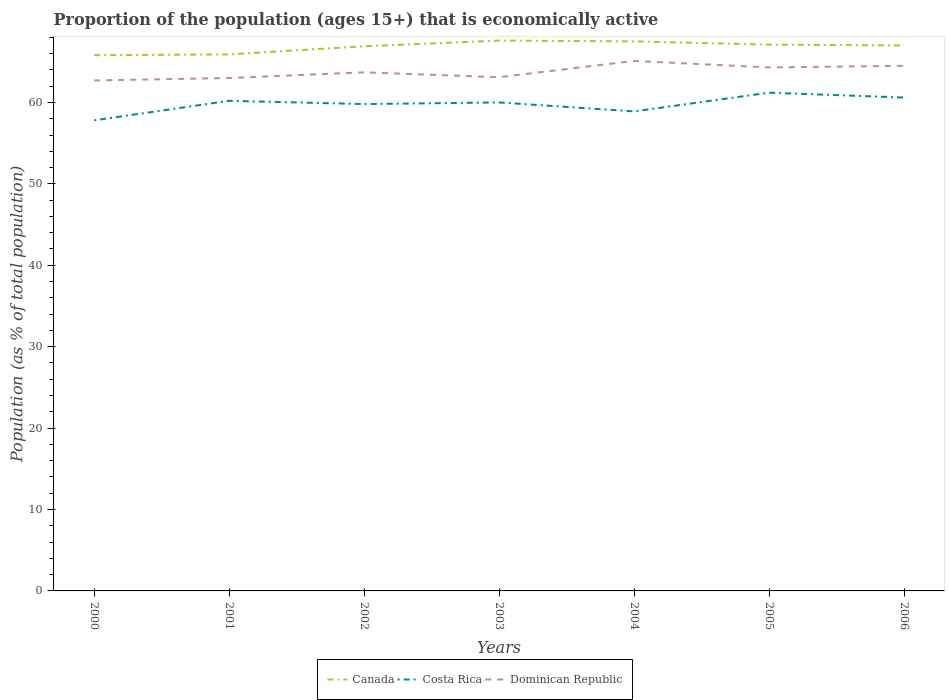Across all years, what is the maximum proportion of the population that is economically active in Canada?
Keep it short and to the point. 65.8. In which year was the proportion of the population that is economically active in Dominican Republic maximum?
Offer a terse response. 2000. What is the total proportion of the population that is economically active in Dominican Republic in the graph?
Give a very brief answer. -0.1. What is the difference between the highest and the second highest proportion of the population that is economically active in Costa Rica?
Keep it short and to the point. 3.4. Is the proportion of the population that is economically active in Costa Rica strictly greater than the proportion of the population that is economically active in Canada over the years?
Provide a succinct answer. Yes. How many years are there in the graph?
Your answer should be very brief. 7. Does the graph contain any zero values?
Keep it short and to the point. No. How are the legend labels stacked?
Offer a terse response. Horizontal. What is the title of the graph?
Your answer should be very brief. Proportion of the population (ages 15+) that is economically active. Does "Congo (Democratic)" appear as one of the legend labels in the graph?
Offer a very short reply. No. What is the label or title of the X-axis?
Make the answer very short. Years. What is the label or title of the Y-axis?
Offer a terse response. Population (as % of total population). What is the Population (as % of total population) in Canada in 2000?
Give a very brief answer. 65.8. What is the Population (as % of total population) of Costa Rica in 2000?
Keep it short and to the point. 57.8. What is the Population (as % of total population) in Dominican Republic in 2000?
Your answer should be compact. 62.7. What is the Population (as % of total population) in Canada in 2001?
Offer a terse response. 65.9. What is the Population (as % of total population) of Costa Rica in 2001?
Your answer should be compact. 60.2. What is the Population (as % of total population) of Canada in 2002?
Your answer should be very brief. 66.9. What is the Population (as % of total population) of Costa Rica in 2002?
Keep it short and to the point. 59.8. What is the Population (as % of total population) in Dominican Republic in 2002?
Your answer should be very brief. 63.7. What is the Population (as % of total population) in Canada in 2003?
Your answer should be very brief. 67.6. What is the Population (as % of total population) in Costa Rica in 2003?
Keep it short and to the point. 60. What is the Population (as % of total population) of Dominican Republic in 2003?
Keep it short and to the point. 63.1. What is the Population (as % of total population) in Canada in 2004?
Keep it short and to the point. 67.5. What is the Population (as % of total population) of Costa Rica in 2004?
Provide a succinct answer. 58.9. What is the Population (as % of total population) of Dominican Republic in 2004?
Offer a very short reply. 65.1. What is the Population (as % of total population) in Canada in 2005?
Provide a succinct answer. 67.1. What is the Population (as % of total population) in Costa Rica in 2005?
Offer a terse response. 61.2. What is the Population (as % of total population) in Dominican Republic in 2005?
Ensure brevity in your answer.  64.3. What is the Population (as % of total population) in Canada in 2006?
Keep it short and to the point. 67. What is the Population (as % of total population) of Costa Rica in 2006?
Provide a succinct answer. 60.6. What is the Population (as % of total population) in Dominican Republic in 2006?
Keep it short and to the point. 64.5. Across all years, what is the maximum Population (as % of total population) of Canada?
Ensure brevity in your answer.  67.6. Across all years, what is the maximum Population (as % of total population) in Costa Rica?
Keep it short and to the point. 61.2. Across all years, what is the maximum Population (as % of total population) of Dominican Republic?
Keep it short and to the point. 65.1. Across all years, what is the minimum Population (as % of total population) of Canada?
Provide a succinct answer. 65.8. Across all years, what is the minimum Population (as % of total population) in Costa Rica?
Keep it short and to the point. 57.8. Across all years, what is the minimum Population (as % of total population) in Dominican Republic?
Provide a succinct answer. 62.7. What is the total Population (as % of total population) in Canada in the graph?
Make the answer very short. 467.8. What is the total Population (as % of total population) of Costa Rica in the graph?
Provide a succinct answer. 418.5. What is the total Population (as % of total population) of Dominican Republic in the graph?
Provide a short and direct response. 446.4. What is the difference between the Population (as % of total population) in Costa Rica in 2000 and that in 2001?
Your answer should be very brief. -2.4. What is the difference between the Population (as % of total population) in Canada in 2000 and that in 2002?
Your answer should be compact. -1.1. What is the difference between the Population (as % of total population) of Dominican Republic in 2000 and that in 2006?
Your answer should be very brief. -1.8. What is the difference between the Population (as % of total population) of Canada in 2001 and that in 2002?
Your response must be concise. -1. What is the difference between the Population (as % of total population) of Dominican Republic in 2001 and that in 2002?
Make the answer very short. -0.7. What is the difference between the Population (as % of total population) of Canada in 2001 and that in 2003?
Provide a short and direct response. -1.7. What is the difference between the Population (as % of total population) in Costa Rica in 2001 and that in 2003?
Give a very brief answer. 0.2. What is the difference between the Population (as % of total population) in Dominican Republic in 2001 and that in 2003?
Ensure brevity in your answer.  -0.1. What is the difference between the Population (as % of total population) in Costa Rica in 2001 and that in 2004?
Offer a very short reply. 1.3. What is the difference between the Population (as % of total population) in Canada in 2001 and that in 2005?
Give a very brief answer. -1.2. What is the difference between the Population (as % of total population) in Dominican Republic in 2001 and that in 2005?
Ensure brevity in your answer.  -1.3. What is the difference between the Population (as % of total population) of Canada in 2001 and that in 2006?
Offer a very short reply. -1.1. What is the difference between the Population (as % of total population) in Dominican Republic in 2001 and that in 2006?
Provide a succinct answer. -1.5. What is the difference between the Population (as % of total population) of Canada in 2002 and that in 2004?
Your response must be concise. -0.6. What is the difference between the Population (as % of total population) of Costa Rica in 2002 and that in 2005?
Offer a very short reply. -1.4. What is the difference between the Population (as % of total population) of Dominican Republic in 2002 and that in 2005?
Ensure brevity in your answer.  -0.6. What is the difference between the Population (as % of total population) of Canada in 2003 and that in 2004?
Make the answer very short. 0.1. What is the difference between the Population (as % of total population) of Costa Rica in 2003 and that in 2004?
Ensure brevity in your answer.  1.1. What is the difference between the Population (as % of total population) in Canada in 2003 and that in 2005?
Give a very brief answer. 0.5. What is the difference between the Population (as % of total population) of Costa Rica in 2003 and that in 2005?
Offer a very short reply. -1.2. What is the difference between the Population (as % of total population) in Dominican Republic in 2003 and that in 2005?
Offer a terse response. -1.2. What is the difference between the Population (as % of total population) in Canada in 2003 and that in 2006?
Your response must be concise. 0.6. What is the difference between the Population (as % of total population) of Dominican Republic in 2003 and that in 2006?
Your answer should be very brief. -1.4. What is the difference between the Population (as % of total population) in Canada in 2004 and that in 2005?
Keep it short and to the point. 0.4. What is the difference between the Population (as % of total population) of Costa Rica in 2005 and that in 2006?
Provide a short and direct response. 0.6. What is the difference between the Population (as % of total population) in Canada in 2000 and the Population (as % of total population) in Costa Rica in 2001?
Provide a succinct answer. 5.6. What is the difference between the Population (as % of total population) of Canada in 2000 and the Population (as % of total population) of Dominican Republic in 2001?
Provide a short and direct response. 2.8. What is the difference between the Population (as % of total population) of Costa Rica in 2000 and the Population (as % of total population) of Dominican Republic in 2001?
Provide a succinct answer. -5.2. What is the difference between the Population (as % of total population) of Canada in 2000 and the Population (as % of total population) of Costa Rica in 2002?
Give a very brief answer. 6. What is the difference between the Population (as % of total population) of Canada in 2000 and the Population (as % of total population) of Dominican Republic in 2002?
Your answer should be very brief. 2.1. What is the difference between the Population (as % of total population) in Costa Rica in 2000 and the Population (as % of total population) in Dominican Republic in 2002?
Keep it short and to the point. -5.9. What is the difference between the Population (as % of total population) of Canada in 2000 and the Population (as % of total population) of Dominican Republic in 2003?
Ensure brevity in your answer.  2.7. What is the difference between the Population (as % of total population) in Canada in 2000 and the Population (as % of total population) in Costa Rica in 2004?
Ensure brevity in your answer.  6.9. What is the difference between the Population (as % of total population) in Costa Rica in 2000 and the Population (as % of total population) in Dominican Republic in 2004?
Offer a terse response. -7.3. What is the difference between the Population (as % of total population) of Costa Rica in 2000 and the Population (as % of total population) of Dominican Republic in 2006?
Make the answer very short. -6.7. What is the difference between the Population (as % of total population) in Canada in 2001 and the Population (as % of total population) in Costa Rica in 2002?
Ensure brevity in your answer.  6.1. What is the difference between the Population (as % of total population) in Canada in 2001 and the Population (as % of total population) in Dominican Republic in 2002?
Your answer should be compact. 2.2. What is the difference between the Population (as % of total population) of Costa Rica in 2001 and the Population (as % of total population) of Dominican Republic in 2002?
Provide a short and direct response. -3.5. What is the difference between the Population (as % of total population) of Canada in 2001 and the Population (as % of total population) of Dominican Republic in 2003?
Keep it short and to the point. 2.8. What is the difference between the Population (as % of total population) in Canada in 2001 and the Population (as % of total population) in Dominican Republic in 2004?
Offer a very short reply. 0.8. What is the difference between the Population (as % of total population) in Canada in 2001 and the Population (as % of total population) in Dominican Republic in 2005?
Make the answer very short. 1.6. What is the difference between the Population (as % of total population) in Costa Rica in 2001 and the Population (as % of total population) in Dominican Republic in 2005?
Make the answer very short. -4.1. What is the difference between the Population (as % of total population) of Canada in 2001 and the Population (as % of total population) of Costa Rica in 2006?
Give a very brief answer. 5.3. What is the difference between the Population (as % of total population) of Canada in 2002 and the Population (as % of total population) of Dominican Republic in 2003?
Ensure brevity in your answer.  3.8. What is the difference between the Population (as % of total population) of Costa Rica in 2002 and the Population (as % of total population) of Dominican Republic in 2003?
Your answer should be compact. -3.3. What is the difference between the Population (as % of total population) in Canada in 2002 and the Population (as % of total population) in Costa Rica in 2004?
Keep it short and to the point. 8. What is the difference between the Population (as % of total population) in Canada in 2002 and the Population (as % of total population) in Dominican Republic in 2004?
Provide a short and direct response. 1.8. What is the difference between the Population (as % of total population) in Canada in 2002 and the Population (as % of total population) in Dominican Republic in 2005?
Make the answer very short. 2.6. What is the difference between the Population (as % of total population) in Costa Rica in 2002 and the Population (as % of total population) in Dominican Republic in 2006?
Give a very brief answer. -4.7. What is the difference between the Population (as % of total population) of Canada in 2003 and the Population (as % of total population) of Dominican Republic in 2004?
Make the answer very short. 2.5. What is the difference between the Population (as % of total population) in Canada in 2003 and the Population (as % of total population) in Costa Rica in 2005?
Provide a succinct answer. 6.4. What is the difference between the Population (as % of total population) in Canada in 2003 and the Population (as % of total population) in Dominican Republic in 2005?
Make the answer very short. 3.3. What is the difference between the Population (as % of total population) in Costa Rica in 2003 and the Population (as % of total population) in Dominican Republic in 2005?
Offer a terse response. -4.3. What is the difference between the Population (as % of total population) in Canada in 2003 and the Population (as % of total population) in Costa Rica in 2006?
Give a very brief answer. 7. What is the difference between the Population (as % of total population) in Canada in 2004 and the Population (as % of total population) in Dominican Republic in 2005?
Offer a very short reply. 3.2. What is the difference between the Population (as % of total population) in Canada in 2005 and the Population (as % of total population) in Dominican Republic in 2006?
Ensure brevity in your answer.  2.6. What is the average Population (as % of total population) of Canada per year?
Offer a very short reply. 66.83. What is the average Population (as % of total population) of Costa Rica per year?
Keep it short and to the point. 59.79. What is the average Population (as % of total population) in Dominican Republic per year?
Offer a terse response. 63.77. In the year 2000, what is the difference between the Population (as % of total population) in Canada and Population (as % of total population) in Costa Rica?
Provide a short and direct response. 8. In the year 2000, what is the difference between the Population (as % of total population) in Canada and Population (as % of total population) in Dominican Republic?
Make the answer very short. 3.1. In the year 2001, what is the difference between the Population (as % of total population) of Canada and Population (as % of total population) of Dominican Republic?
Offer a very short reply. 2.9. In the year 2001, what is the difference between the Population (as % of total population) of Costa Rica and Population (as % of total population) of Dominican Republic?
Give a very brief answer. -2.8. In the year 2002, what is the difference between the Population (as % of total population) of Canada and Population (as % of total population) of Costa Rica?
Your answer should be compact. 7.1. In the year 2002, what is the difference between the Population (as % of total population) in Canada and Population (as % of total population) in Dominican Republic?
Your answer should be compact. 3.2. In the year 2002, what is the difference between the Population (as % of total population) of Costa Rica and Population (as % of total population) of Dominican Republic?
Provide a succinct answer. -3.9. In the year 2003, what is the difference between the Population (as % of total population) of Canada and Population (as % of total population) of Costa Rica?
Your answer should be very brief. 7.6. In the year 2003, what is the difference between the Population (as % of total population) in Canada and Population (as % of total population) in Dominican Republic?
Your answer should be compact. 4.5. In the year 2003, what is the difference between the Population (as % of total population) of Costa Rica and Population (as % of total population) of Dominican Republic?
Provide a succinct answer. -3.1. In the year 2004, what is the difference between the Population (as % of total population) of Canada and Population (as % of total population) of Dominican Republic?
Your response must be concise. 2.4. In the year 2004, what is the difference between the Population (as % of total population) in Costa Rica and Population (as % of total population) in Dominican Republic?
Give a very brief answer. -6.2. In the year 2005, what is the difference between the Population (as % of total population) in Canada and Population (as % of total population) in Costa Rica?
Make the answer very short. 5.9. In the year 2006, what is the difference between the Population (as % of total population) of Canada and Population (as % of total population) of Dominican Republic?
Provide a short and direct response. 2.5. In the year 2006, what is the difference between the Population (as % of total population) of Costa Rica and Population (as % of total population) of Dominican Republic?
Your answer should be compact. -3.9. What is the ratio of the Population (as % of total population) of Canada in 2000 to that in 2001?
Your answer should be compact. 1. What is the ratio of the Population (as % of total population) in Costa Rica in 2000 to that in 2001?
Your answer should be very brief. 0.96. What is the ratio of the Population (as % of total population) in Canada in 2000 to that in 2002?
Ensure brevity in your answer.  0.98. What is the ratio of the Population (as % of total population) in Costa Rica in 2000 to that in 2002?
Provide a succinct answer. 0.97. What is the ratio of the Population (as % of total population) in Dominican Republic in 2000 to that in 2002?
Make the answer very short. 0.98. What is the ratio of the Population (as % of total population) of Canada in 2000 to that in 2003?
Make the answer very short. 0.97. What is the ratio of the Population (as % of total population) of Costa Rica in 2000 to that in 2003?
Keep it short and to the point. 0.96. What is the ratio of the Population (as % of total population) in Canada in 2000 to that in 2004?
Ensure brevity in your answer.  0.97. What is the ratio of the Population (as % of total population) in Costa Rica in 2000 to that in 2004?
Ensure brevity in your answer.  0.98. What is the ratio of the Population (as % of total population) in Dominican Republic in 2000 to that in 2004?
Provide a succinct answer. 0.96. What is the ratio of the Population (as % of total population) in Canada in 2000 to that in 2005?
Provide a succinct answer. 0.98. What is the ratio of the Population (as % of total population) in Dominican Republic in 2000 to that in 2005?
Ensure brevity in your answer.  0.98. What is the ratio of the Population (as % of total population) of Canada in 2000 to that in 2006?
Keep it short and to the point. 0.98. What is the ratio of the Population (as % of total population) of Costa Rica in 2000 to that in 2006?
Offer a terse response. 0.95. What is the ratio of the Population (as % of total population) of Dominican Republic in 2000 to that in 2006?
Make the answer very short. 0.97. What is the ratio of the Population (as % of total population) in Canada in 2001 to that in 2002?
Offer a very short reply. 0.99. What is the ratio of the Population (as % of total population) of Costa Rica in 2001 to that in 2002?
Your answer should be very brief. 1.01. What is the ratio of the Population (as % of total population) of Canada in 2001 to that in 2003?
Provide a short and direct response. 0.97. What is the ratio of the Population (as % of total population) of Canada in 2001 to that in 2004?
Offer a terse response. 0.98. What is the ratio of the Population (as % of total population) in Costa Rica in 2001 to that in 2004?
Your answer should be very brief. 1.02. What is the ratio of the Population (as % of total population) of Canada in 2001 to that in 2005?
Your answer should be very brief. 0.98. What is the ratio of the Population (as % of total population) of Costa Rica in 2001 to that in 2005?
Offer a very short reply. 0.98. What is the ratio of the Population (as % of total population) of Dominican Republic in 2001 to that in 2005?
Provide a short and direct response. 0.98. What is the ratio of the Population (as % of total population) of Canada in 2001 to that in 2006?
Provide a short and direct response. 0.98. What is the ratio of the Population (as % of total population) in Costa Rica in 2001 to that in 2006?
Your response must be concise. 0.99. What is the ratio of the Population (as % of total population) of Dominican Republic in 2001 to that in 2006?
Your answer should be compact. 0.98. What is the ratio of the Population (as % of total population) in Dominican Republic in 2002 to that in 2003?
Keep it short and to the point. 1.01. What is the ratio of the Population (as % of total population) in Costa Rica in 2002 to that in 2004?
Your answer should be compact. 1.02. What is the ratio of the Population (as % of total population) of Dominican Republic in 2002 to that in 2004?
Provide a succinct answer. 0.98. What is the ratio of the Population (as % of total population) in Canada in 2002 to that in 2005?
Make the answer very short. 1. What is the ratio of the Population (as % of total population) of Costa Rica in 2002 to that in 2005?
Give a very brief answer. 0.98. What is the ratio of the Population (as % of total population) of Dominican Republic in 2002 to that in 2006?
Offer a terse response. 0.99. What is the ratio of the Population (as % of total population) in Costa Rica in 2003 to that in 2004?
Keep it short and to the point. 1.02. What is the ratio of the Population (as % of total population) of Dominican Republic in 2003 to that in 2004?
Your response must be concise. 0.97. What is the ratio of the Population (as % of total population) in Canada in 2003 to that in 2005?
Offer a terse response. 1.01. What is the ratio of the Population (as % of total population) in Costa Rica in 2003 to that in 2005?
Offer a terse response. 0.98. What is the ratio of the Population (as % of total population) in Dominican Republic in 2003 to that in 2005?
Offer a very short reply. 0.98. What is the ratio of the Population (as % of total population) of Canada in 2003 to that in 2006?
Offer a very short reply. 1.01. What is the ratio of the Population (as % of total population) in Dominican Republic in 2003 to that in 2006?
Give a very brief answer. 0.98. What is the ratio of the Population (as % of total population) of Canada in 2004 to that in 2005?
Give a very brief answer. 1.01. What is the ratio of the Population (as % of total population) in Costa Rica in 2004 to that in 2005?
Keep it short and to the point. 0.96. What is the ratio of the Population (as % of total population) in Dominican Republic in 2004 to that in 2005?
Make the answer very short. 1.01. What is the ratio of the Population (as % of total population) in Canada in 2004 to that in 2006?
Ensure brevity in your answer.  1.01. What is the ratio of the Population (as % of total population) of Costa Rica in 2004 to that in 2006?
Provide a succinct answer. 0.97. What is the ratio of the Population (as % of total population) of Dominican Republic in 2004 to that in 2006?
Offer a terse response. 1.01. What is the ratio of the Population (as % of total population) in Costa Rica in 2005 to that in 2006?
Offer a terse response. 1.01. What is the difference between the highest and the lowest Population (as % of total population) in Canada?
Offer a terse response. 1.8. What is the difference between the highest and the lowest Population (as % of total population) of Costa Rica?
Ensure brevity in your answer.  3.4. What is the difference between the highest and the lowest Population (as % of total population) in Dominican Republic?
Make the answer very short. 2.4. 